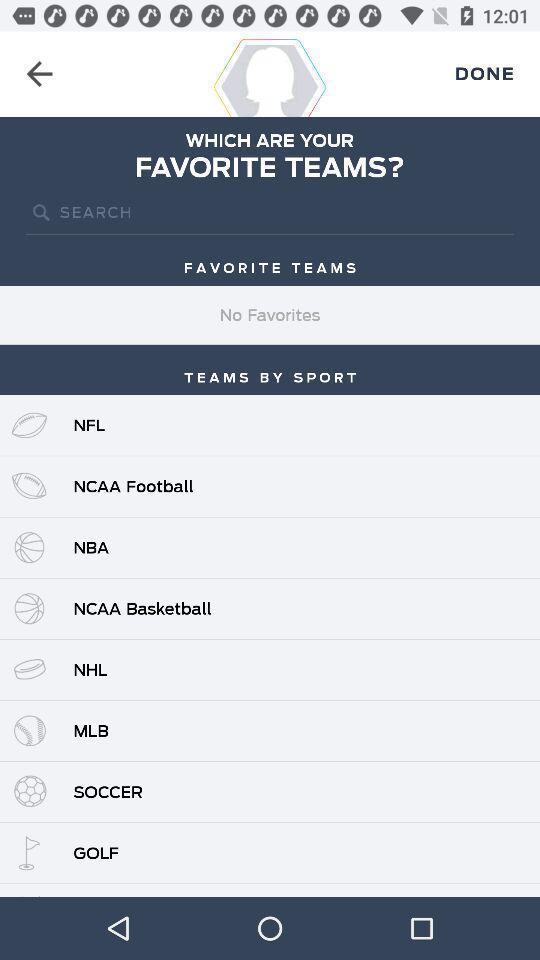Explain the elements present in this screenshot. Search results of teams by sport. 